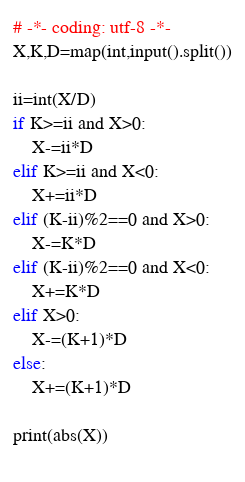Convert code to text. <code><loc_0><loc_0><loc_500><loc_500><_Python_># -*- coding: utf-8 -*-
X,K,D=map(int,input().split())

ii=int(X/D)
if K>=ii and X>0:
    X-=ii*D
elif K>=ii and X<0:
    X+=ii*D
elif (K-ii)%2==0 and X>0:
    X-=K*D
elif (K-ii)%2==0 and X<0:
    X+=K*D
elif X>0:
    X-=(K+1)*D
else:
    X+=(K+1)*D

print(abs(X))
        
</code> 